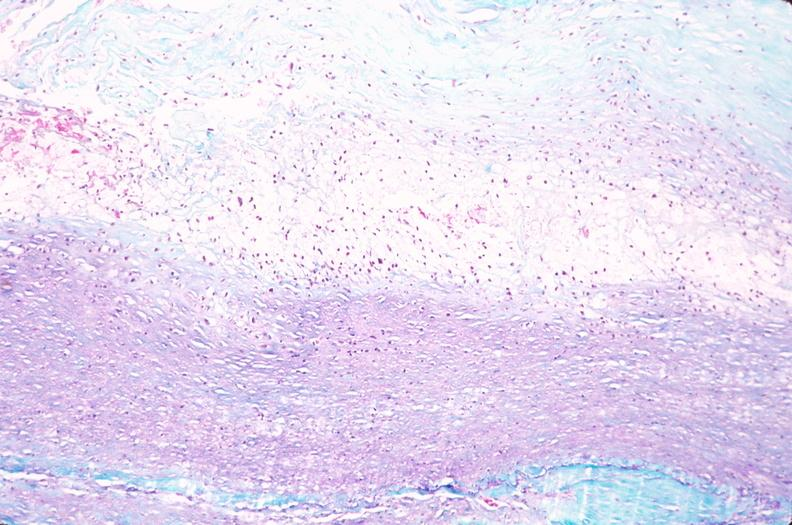what is present?
Answer the question using a single word or phrase. Vasculature 